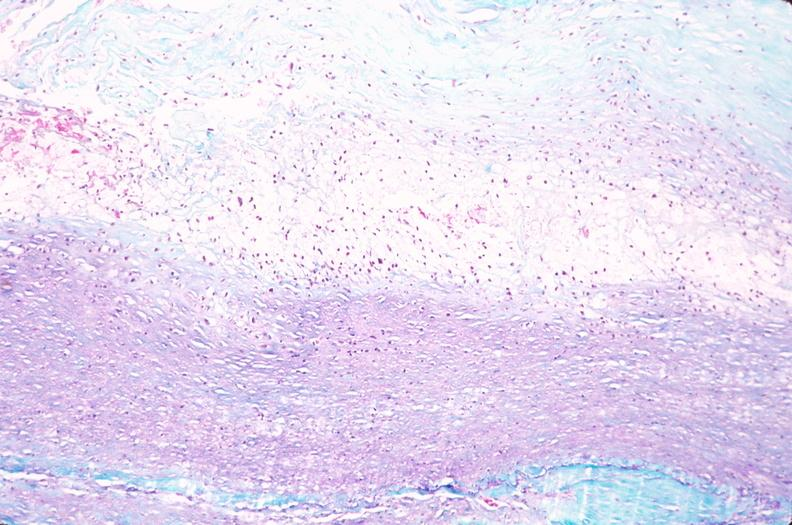what is present?
Answer the question using a single word or phrase. Vasculature 